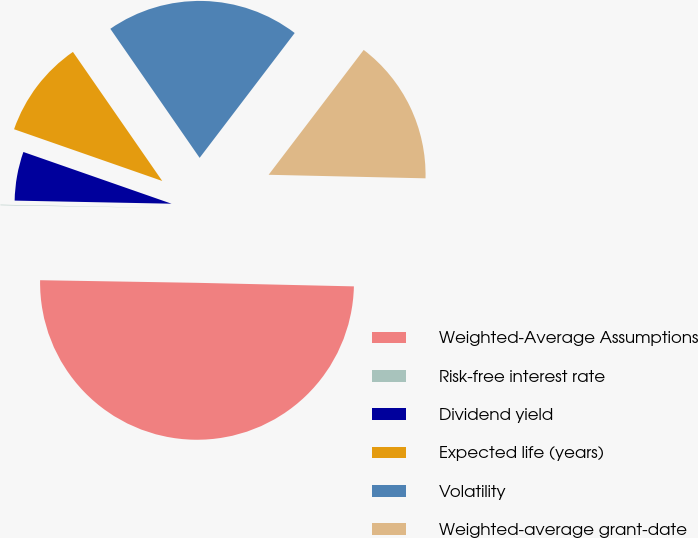Convert chart. <chart><loc_0><loc_0><loc_500><loc_500><pie_chart><fcel>Weighted-Average Assumptions<fcel>Risk-free interest rate<fcel>Dividend yield<fcel>Expected life (years)<fcel>Volatility<fcel>Weighted-average grant-date<nl><fcel>49.9%<fcel>0.05%<fcel>5.03%<fcel>10.02%<fcel>19.99%<fcel>15.0%<nl></chart> 